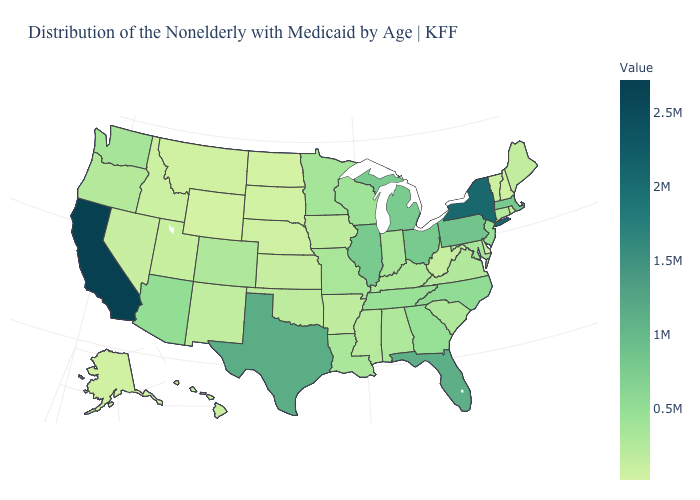Is the legend a continuous bar?
Write a very short answer. Yes. Which states have the lowest value in the USA?
Give a very brief answer. North Dakota. Is the legend a continuous bar?
Quick response, please. Yes. Does Vermont have the highest value in the USA?
Keep it brief. No. Which states have the lowest value in the USA?
Short answer required. North Dakota. Does the map have missing data?
Write a very short answer. No. Which states hav the highest value in the MidWest?
Be succinct. Ohio. Does Illinois have a lower value than Louisiana?
Short answer required. No. Which states have the lowest value in the USA?
Concise answer only. North Dakota. 